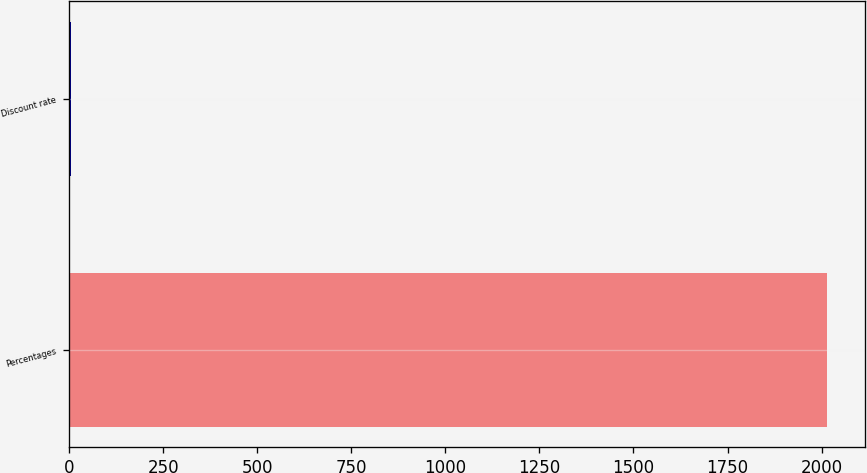Convert chart. <chart><loc_0><loc_0><loc_500><loc_500><bar_chart><fcel>Percentages<fcel>Discount rate<nl><fcel>2014<fcel>4.35<nl></chart> 